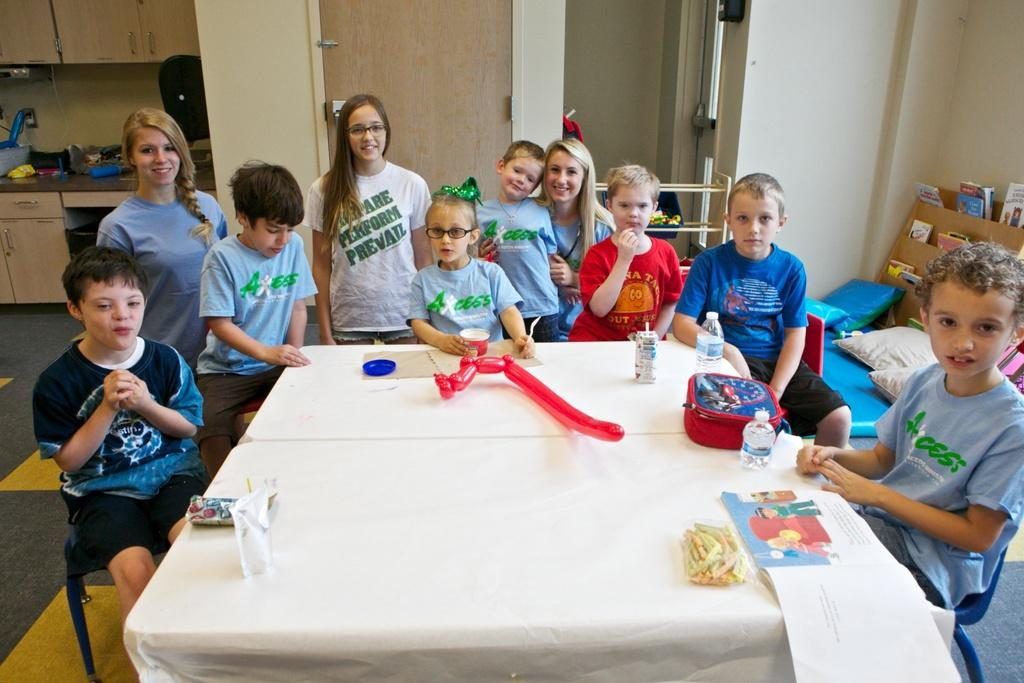Who is present in the image? There are children and women in the image. What is the emotional state of some of the people in the image? Some of the people in the image are smiling. What can be seen in the background of the image? There are cabinets, a wall, a door, and pillows in the background of the image. What type of story is being told by the children in the image? There is no indication in the image that the children are telling a story. What is being served for lunch in the image? There is no reference to lunch or any food in the image. 